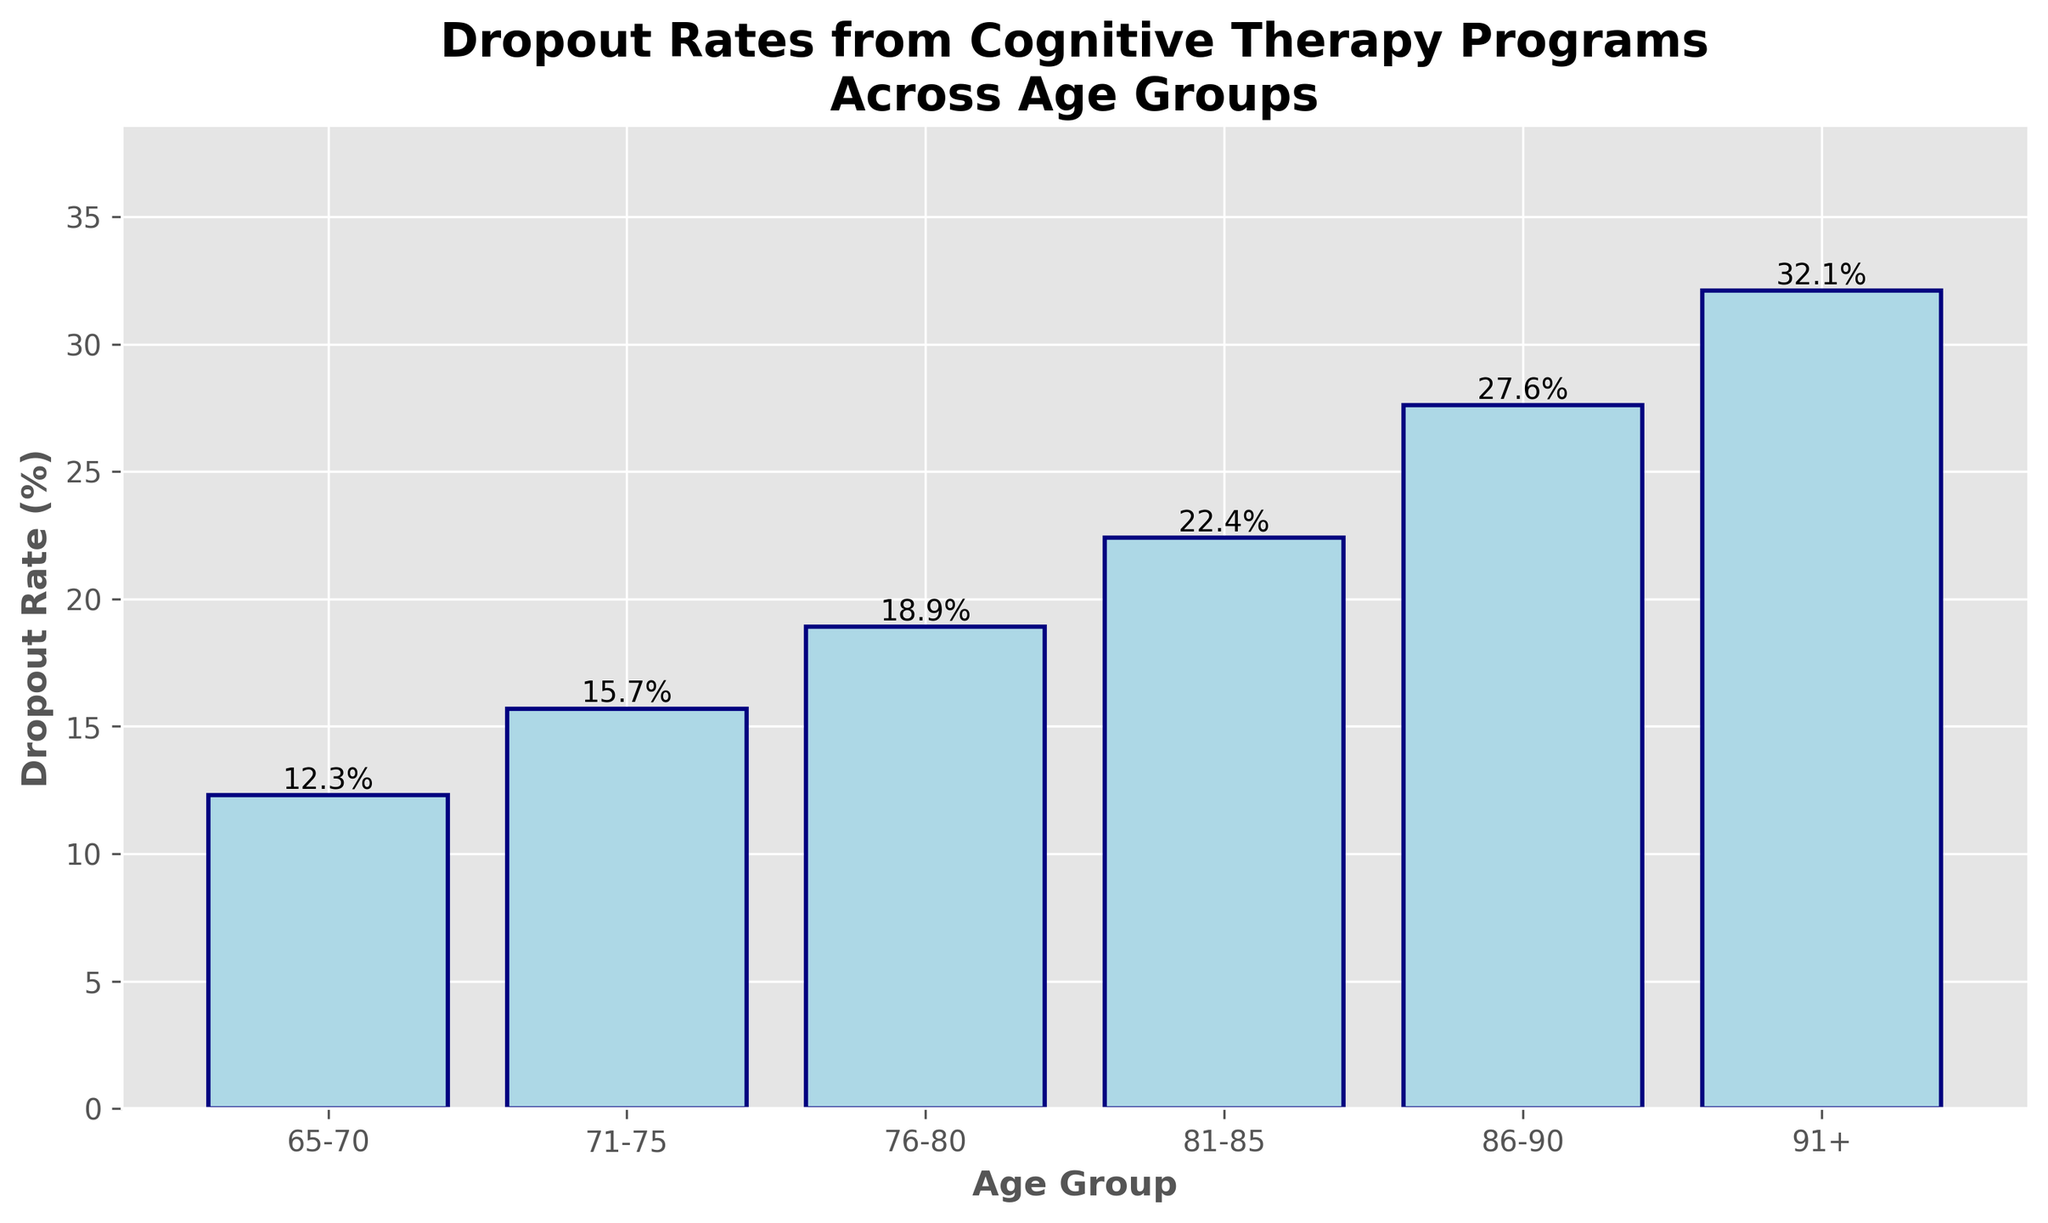What is the dropout rate for the age group 81-85? Looking at the bar associated with the age group 81-85, the height of the bar indicates the dropout rate. The text at the top of the bar shows 22.4%.
Answer: 22.4% Which age group has the highest dropout rate? By comparing the heights of all the bars, the tallest bar corresponds to the age group 91+. The text at the top of this bar shows a dropout rate of 32.1%.
Answer: 91+ How much higher is the dropout rate for the age group 91+ compared to the age group 65-70? The dropout rate for 91+ is 32.1%, and for 65-70, it is 12.3%. Subtract the latter from the former: 32.1% - 12.3% = 19.8%.
Answer: 19.8% What is the average dropout rate across all age groups? Add up all the dropout rates and divide by the number of age groups: (12.3 + 15.7 + 18.9 + 22.4 + 27.6 + 32.1) / 6 = 21.5%.
Answer: 21.5% Is there a noticeable trend in dropout rates as age increases? Observing the graph, the dropout rate increases steadily across the age groups from 65-70 to 91+. Each subsequent age group has a higher dropout rate than the previous one, indicating an upward trend.
Answer: Yes What is the median dropout rate across the age groups? Arrange the dropout rates in ascending order: 12.3%, 15.7%, 18.9%, 22.4%, 27.6%, and 32.1%. The median is the average of the 3rd and 4th values: (18.9 + 22.4) / 2 = 20.65%.
Answer: 20.65% How does the dropout rate for the age group 86-90 compare to the overall average dropout rate? The dropout rate for 86-90 is 27.6% and the overall average is 21.5%. Since 27.6% > 21.5%, the dropout rate for 86-90 is higher than the overall average.
Answer: Higher Which age group has a dropout rate closest to 20%? The dropout rates are: 12.3%, 15.7%, 18.9%, 22.4%, 27.6%, and 32.1%. The value closest to 20% is 18.9%, which corresponds to the age group 76-80.
Answer: 76-80 